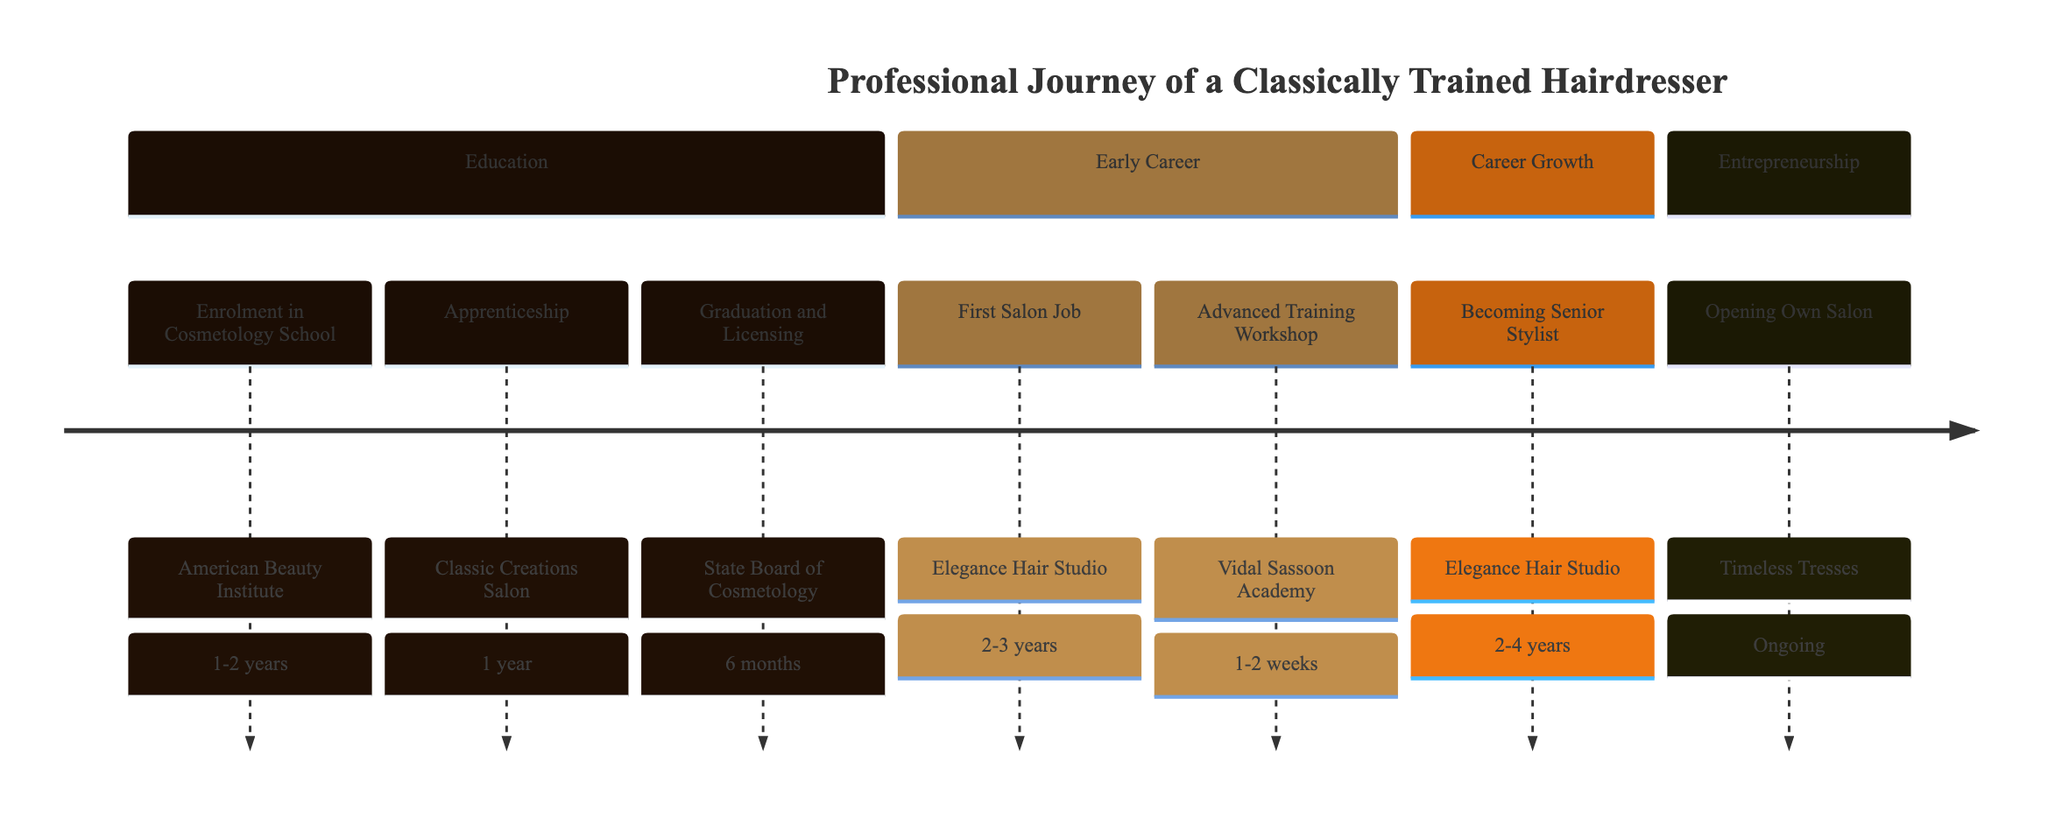What is the first milestone in the timeline? The first milestone is "Enrolment in Cosmetology School," which is shown at the top of the timeline. It indicates the start of formal education in the journey of a hairdresser.
Answer: Enrolment in Cosmetology School How many years does the apprenticeship last? The duration of the apprenticeship, which is the second milestone in the timeline, is stated as "1 year." This is specific to the hands-on training phase.
Answer: 1 year What institution is associated with the advanced training workshop? The advanced training workshop is linked to "Vidal Sassoon Academy," which is listed in the timeline as the institution where the workshop takes place.
Answer: Vidal Sassoon Academy How long does it take to become a senior stylist after the first salon job? The timeline indicates that becoming a senior stylist takes "2-4 years" after starting the first salon job, an important transition in the career path.
Answer: 2-4 years What is the ongoing milestone in the timeline? The ongoing milestone, which represents a continuous process in the career journey, is "Opening Own Salon," referred to as "Timeless Tresses" in the timeline.
Answer: Opening Own Salon Which entity certifies the graduation and licensing? The entity that certifies graduation and licensing is the "State Board of Cosmetology," as noted in the description of that milestone on the timeline.
Answer: State Board of Cosmetology What is the duration of the advanced training workshop? The duration of the advanced training workshop is detailed as "1-2 weeks" in the timeline, which emphasizes the short yet intensive nature of further training.
Answer: 1-2 weeks What role does John Doe play in the apprenticeship? John Doe is identified as the mentor during the apprenticeship, which is a crucial hands-on training stage for the hairdresser.
Answer: Mentor What is the average duration of the first salon job? The timeline specifies that the duration of the first salon job is "2-3 years," indicating the period spent gaining experience in a professional setting.
Answer: 2-3 years 